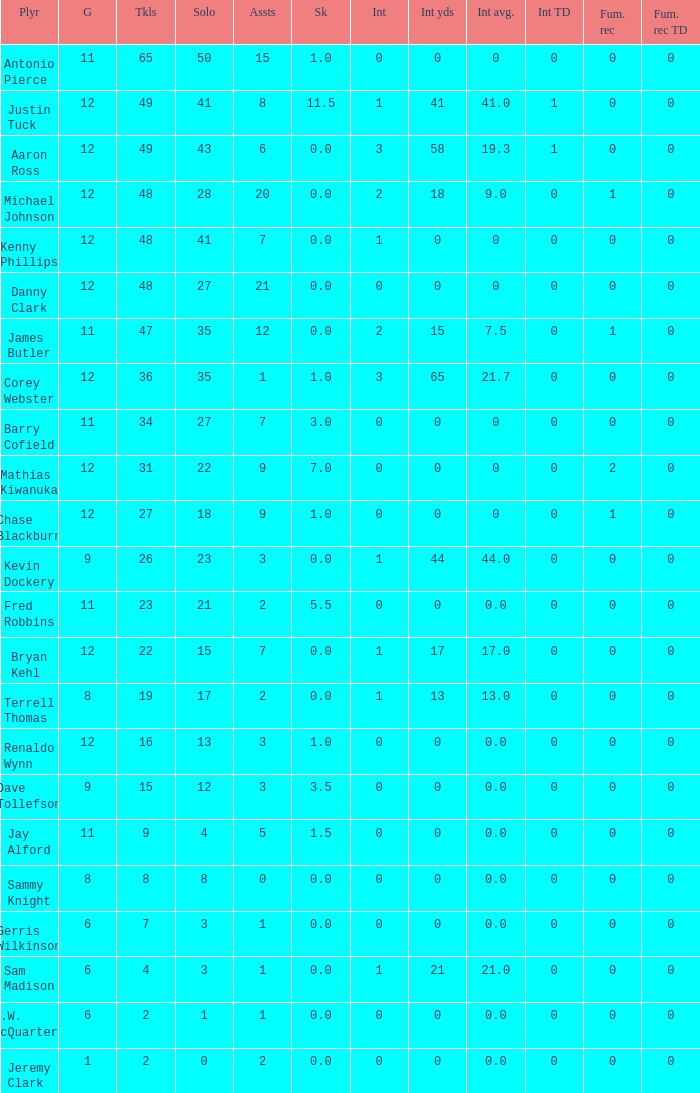Name the least int yards when sacks is 11.5 41.0. 